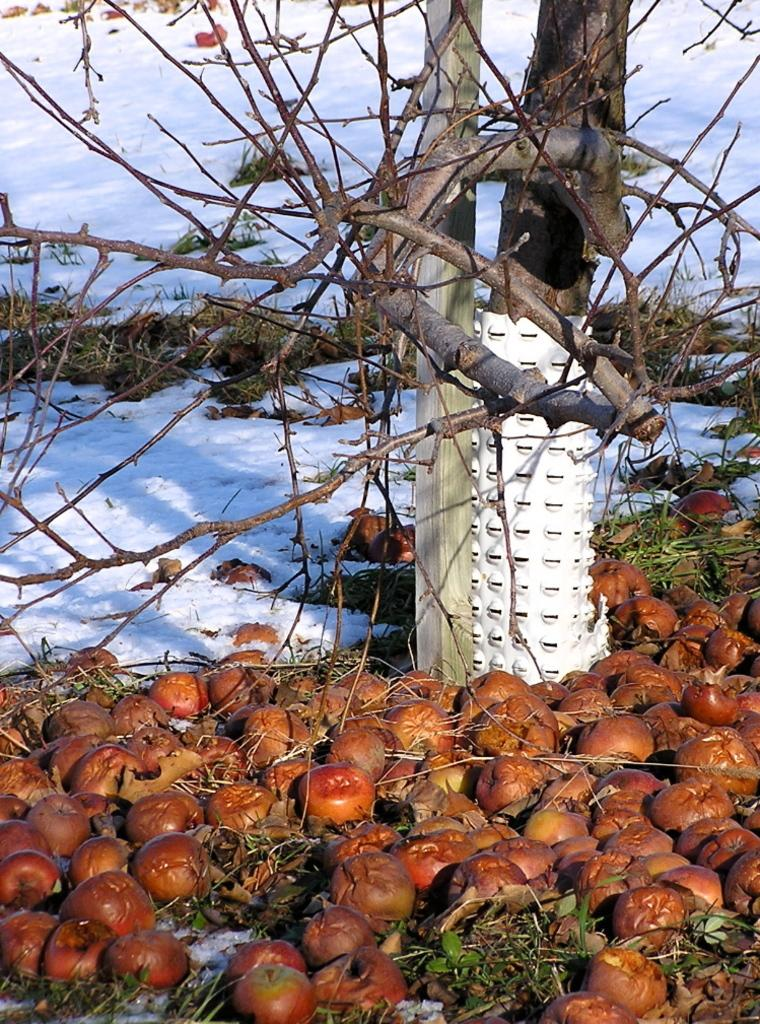What type of plant can be seen in the image? There is a tree in the image. What is located near the tree? There are apples near the tree. What is the condition of the ground near the tree? The ground near the tree is covered in snow. What type of lettuce can be seen growing near the tree in the image? There is no lettuce present in the image; only a tree and apples are visible. 